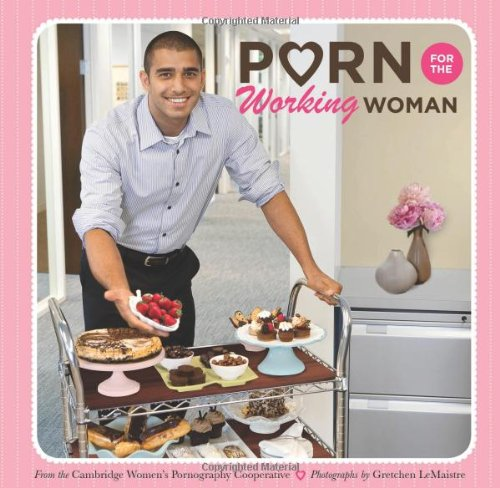Who is the author of this book?
Answer the question using a single word or phrase. Cambridge Women's Pornography Cooperative What is the title of this book? Porn for the Working Woman What is the genre of this book? Humor & Entertainment Is this a comedy book? Yes 